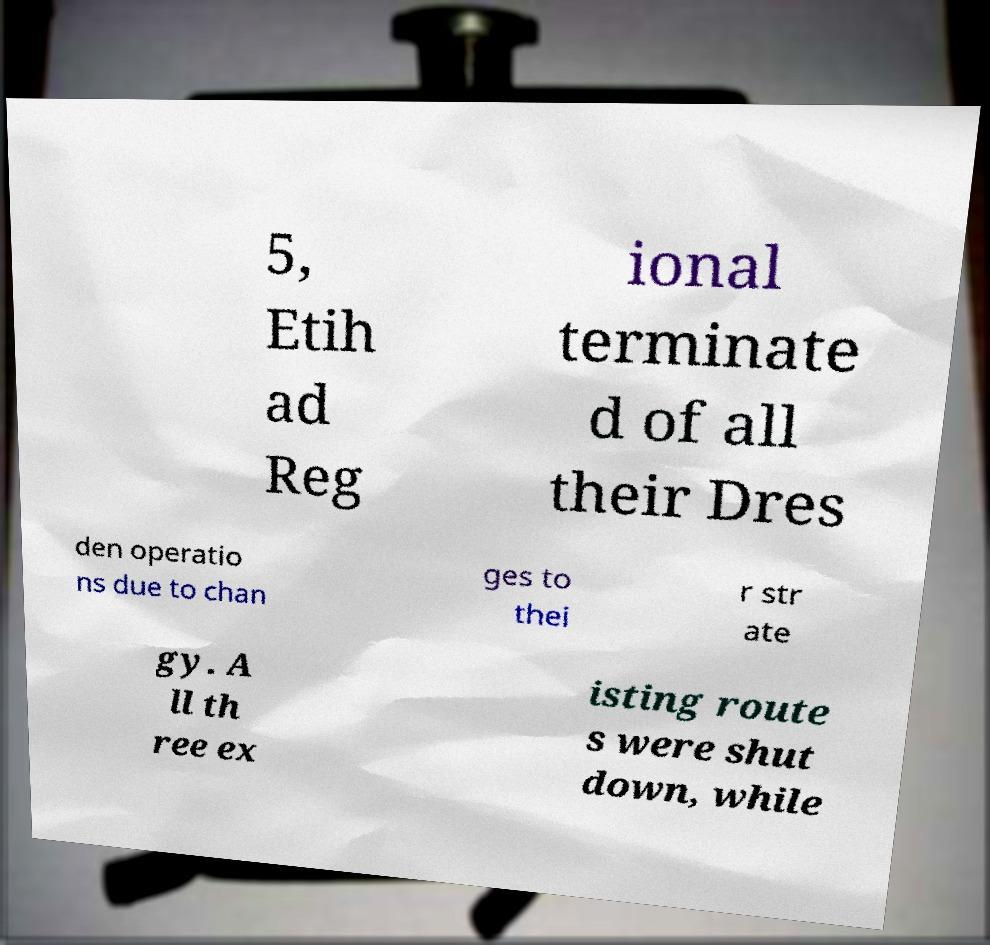Could you assist in decoding the text presented in this image and type it out clearly? 5, Etih ad Reg ional terminate d of all their Dres den operatio ns due to chan ges to thei r str ate gy. A ll th ree ex isting route s were shut down, while 